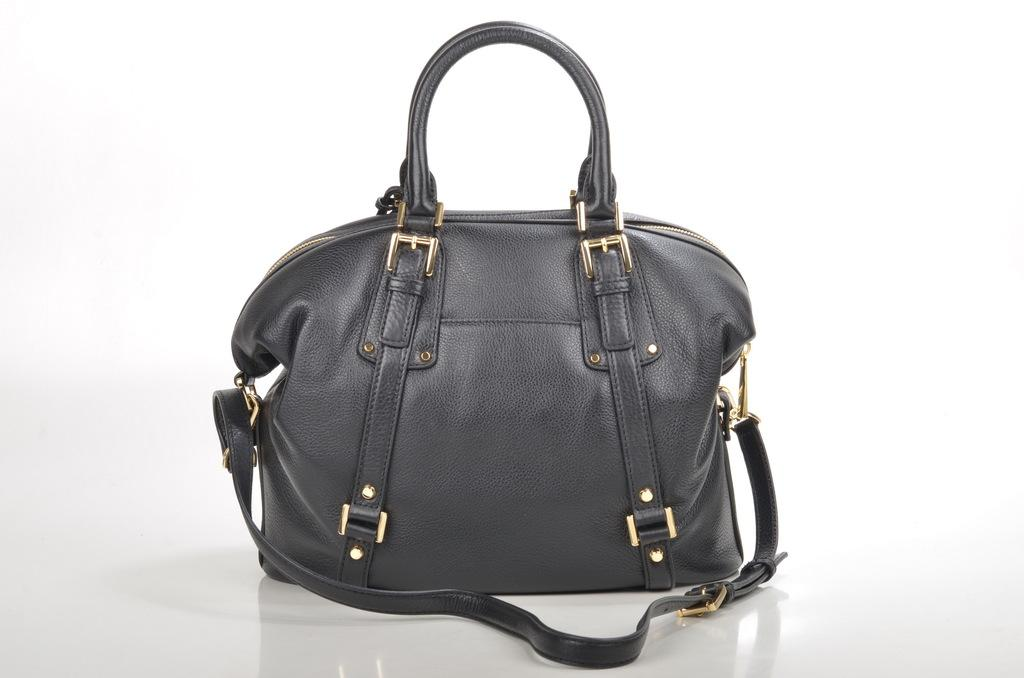What type of handbag is visible in the image? There is a black handbag in the image. What color are the chains on the handbag? The handbag has gold color chains. How can the contents of the handbag be secured? The handbag has a zip on top. What feature is present inside the handbag to help organize its contents? There is a U-shaped partition inside the handbag. How many members are in the committee that designed the handbag? There is no information about a committee or its members in the image, as it only shows a black handbag with specific features. 